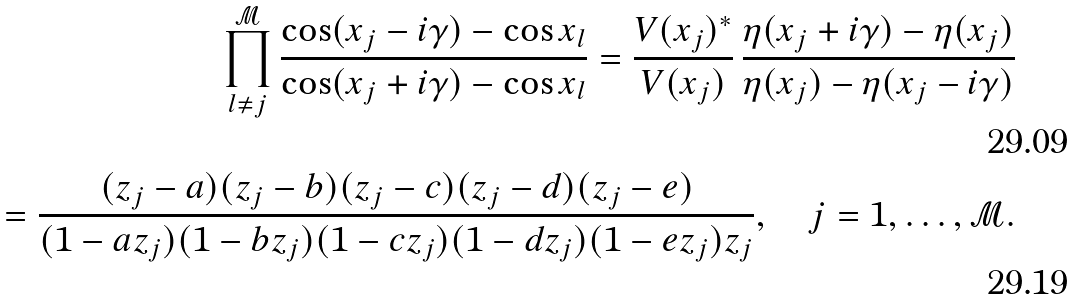Convert formula to latex. <formula><loc_0><loc_0><loc_500><loc_500>\prod _ { l \neq j } ^ { \mathcal { M } } \frac { \cos ( x _ { j } - i \gamma ) - \cos x _ { l } } { \cos ( x _ { j } + i \gamma ) - \cos x _ { l } } = \frac { V ( x _ { j } ) ^ { * } } { V ( x _ { j } ) } \, \frac { \eta ( x _ { j } + i \gamma ) - \eta ( x _ { j } ) } { \eta ( x _ { j } ) - \eta ( x _ { j } - i \gamma ) } \\ = \frac { ( z _ { j } - a ) ( z _ { j } - b ) ( z _ { j } - c ) ( z _ { j } - d ) ( z _ { j } - e ) } { ( 1 - a z _ { j } ) ( 1 - b z _ { j } ) ( 1 - c z _ { j } ) ( 1 - d z _ { j } ) ( 1 - e z _ { j } ) z _ { j } } , \quad j = 1 , \dots , { \mathcal { M } } .</formula> 